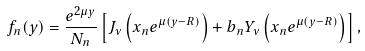Convert formula to latex. <formula><loc_0><loc_0><loc_500><loc_500>f _ { n } ( y ) = \frac { e ^ { 2 \mu y } } { N _ { n } } \left [ J _ { \nu } \left ( x _ { n } e ^ { \mu ( y - R ) } \right ) + b _ { n } Y _ { \nu } \left ( x _ { n } e ^ { \mu ( y - R ) } \right ) \right ] ,</formula> 